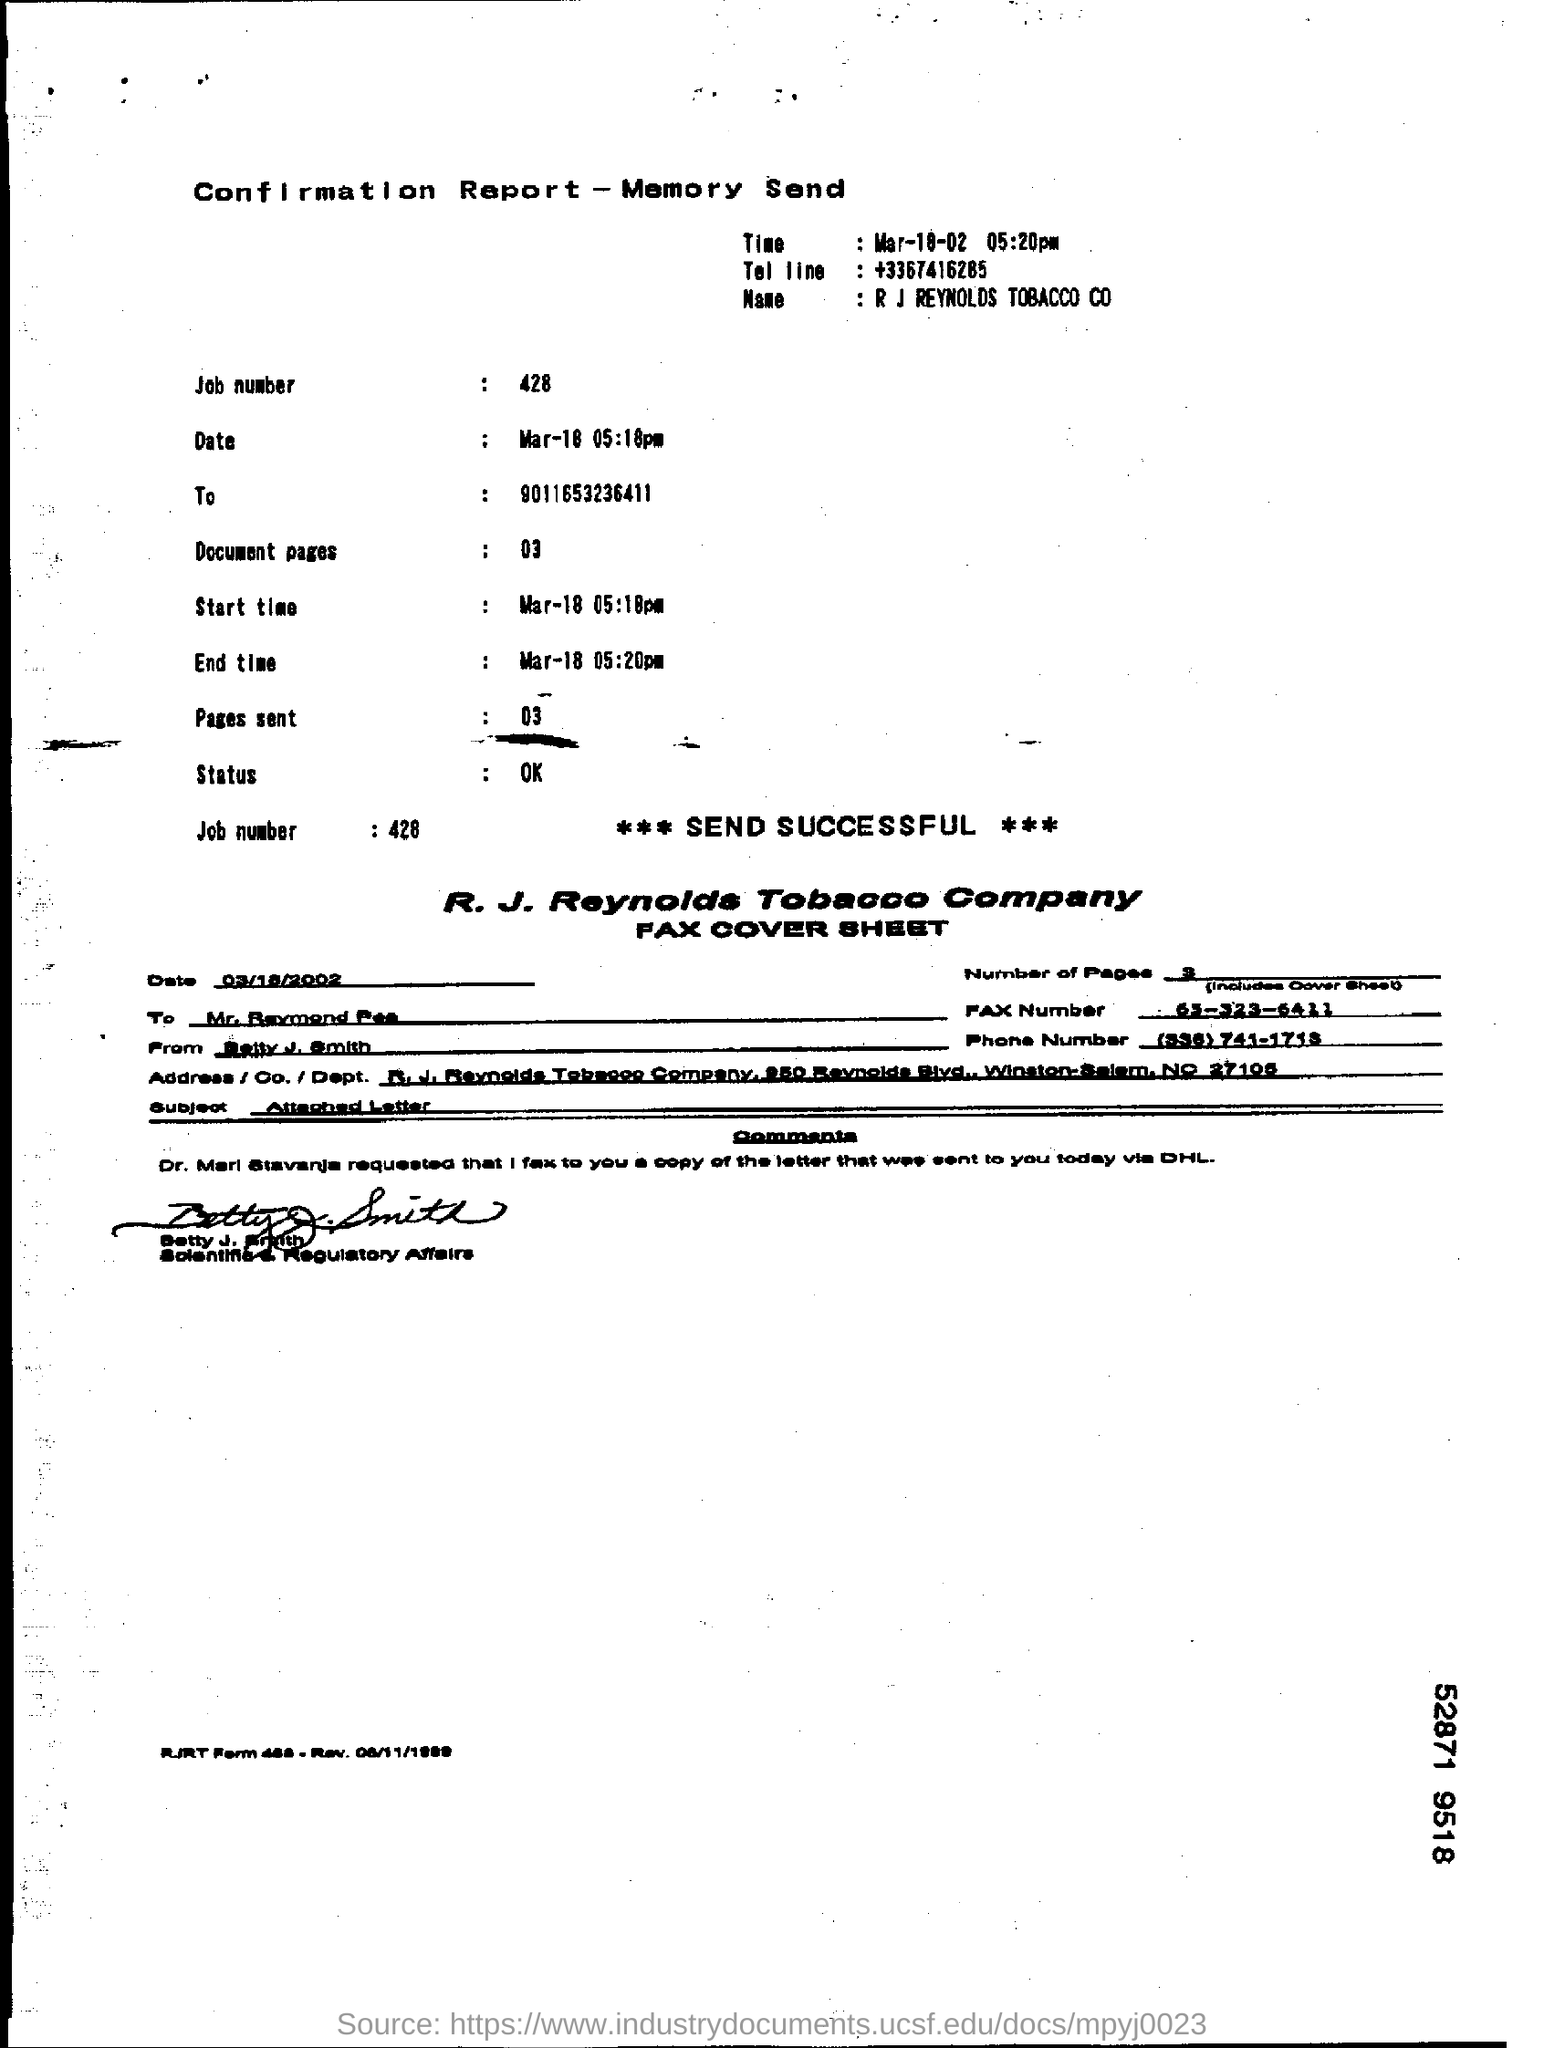Specify some key components in this picture. The subject of the fax cover sheet is the attached letter. The job number is 428. 